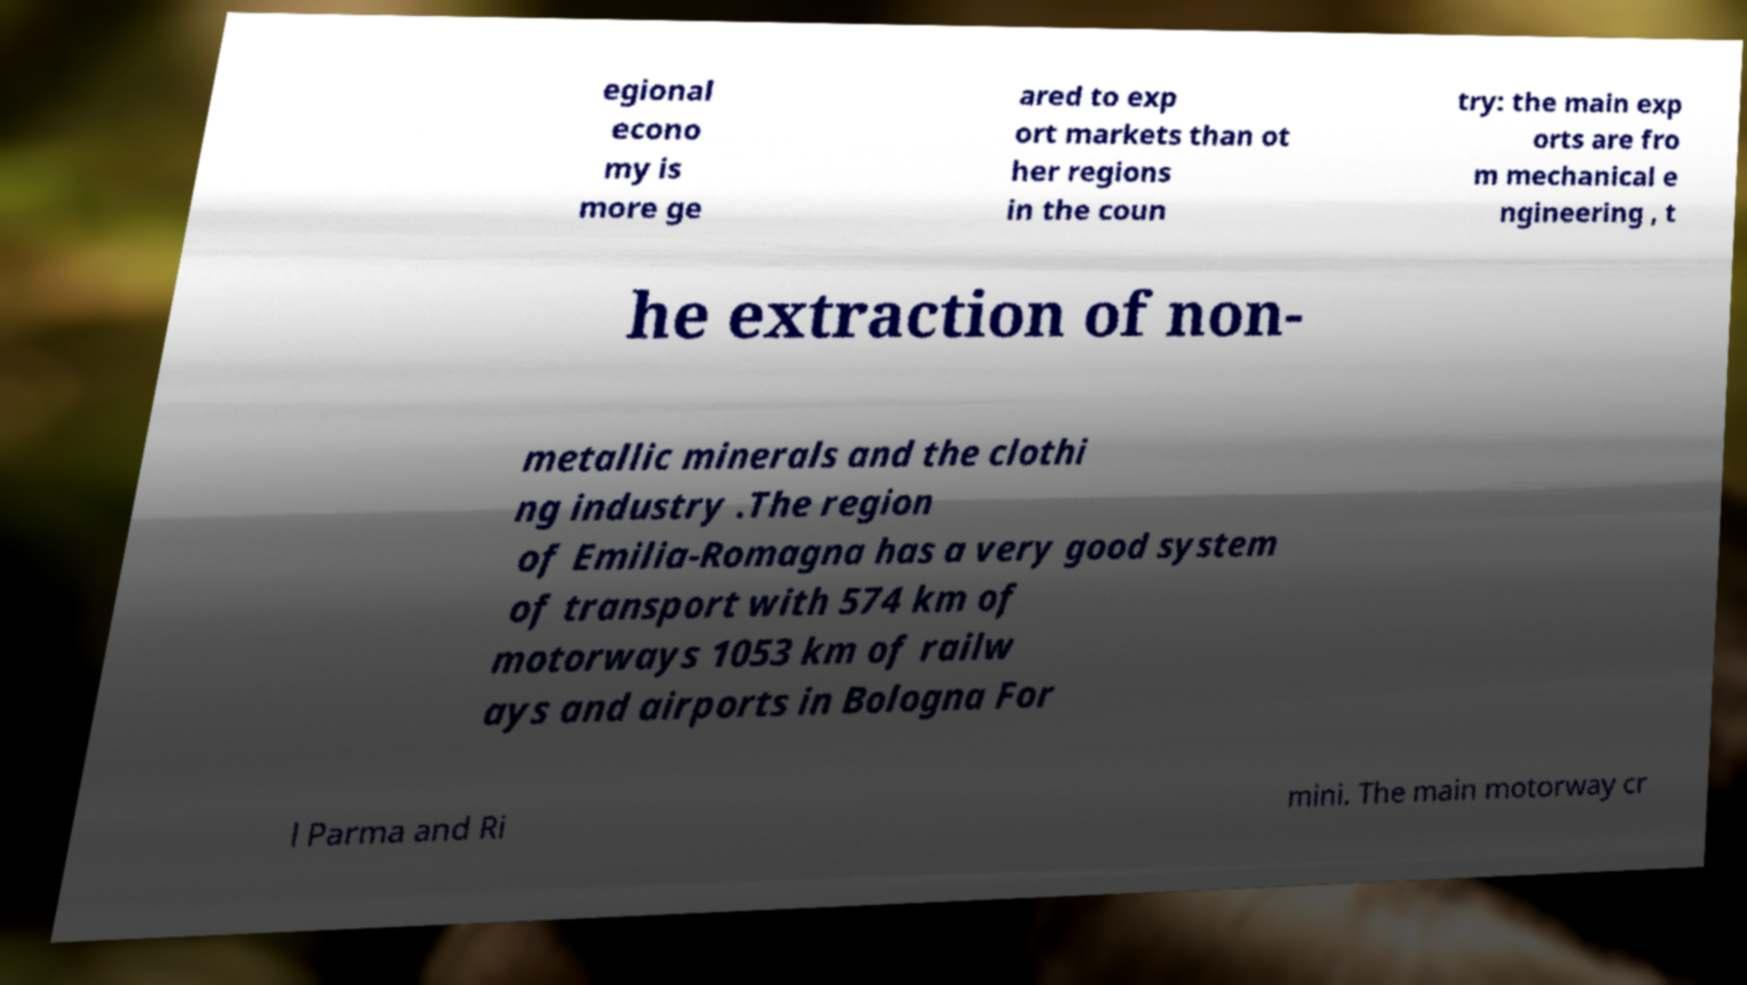There's text embedded in this image that I need extracted. Can you transcribe it verbatim? egional econo my is more ge ared to exp ort markets than ot her regions in the coun try: the main exp orts are fro m mechanical e ngineering , t he extraction of non- metallic minerals and the clothi ng industry .The region of Emilia-Romagna has a very good system of transport with 574 km of motorways 1053 km of railw ays and airports in Bologna For l Parma and Ri mini. The main motorway cr 